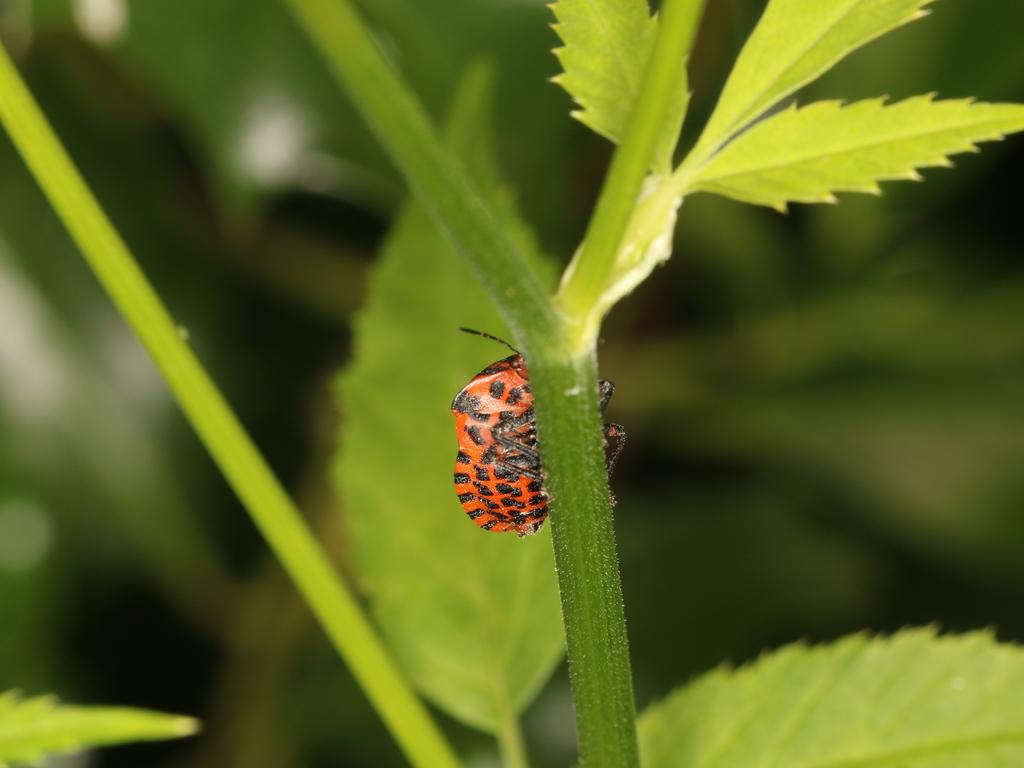What is present in the picture? There is a plant in the picture. What can be observed about the plant? The plant has leaves, and there is a bug on its stem. What is the color of the stem? The stem is orange in color. Are there any other notable features on the stem? Yes, the stem has black dots on it. What does the plant say in the image? Plants do not have the ability to speak or write, so there is no text or dialogue present in the image. 